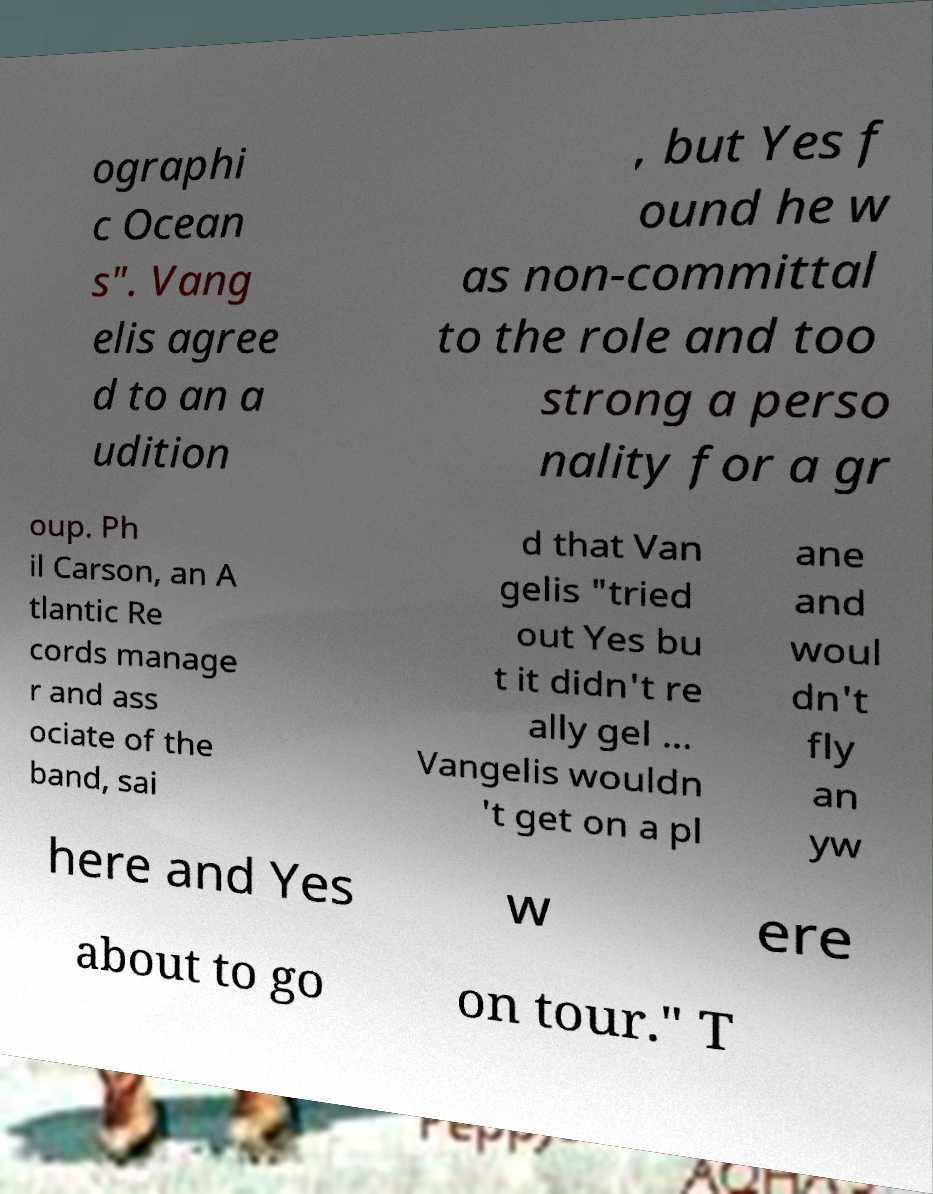There's text embedded in this image that I need extracted. Can you transcribe it verbatim? ographi c Ocean s". Vang elis agree d to an a udition , but Yes f ound he w as non-committal to the role and too strong a perso nality for a gr oup. Ph il Carson, an A tlantic Re cords manage r and ass ociate of the band, sai d that Van gelis "tried out Yes bu t it didn't re ally gel ... Vangelis wouldn 't get on a pl ane and woul dn't fly an yw here and Yes w ere about to go on tour." T 